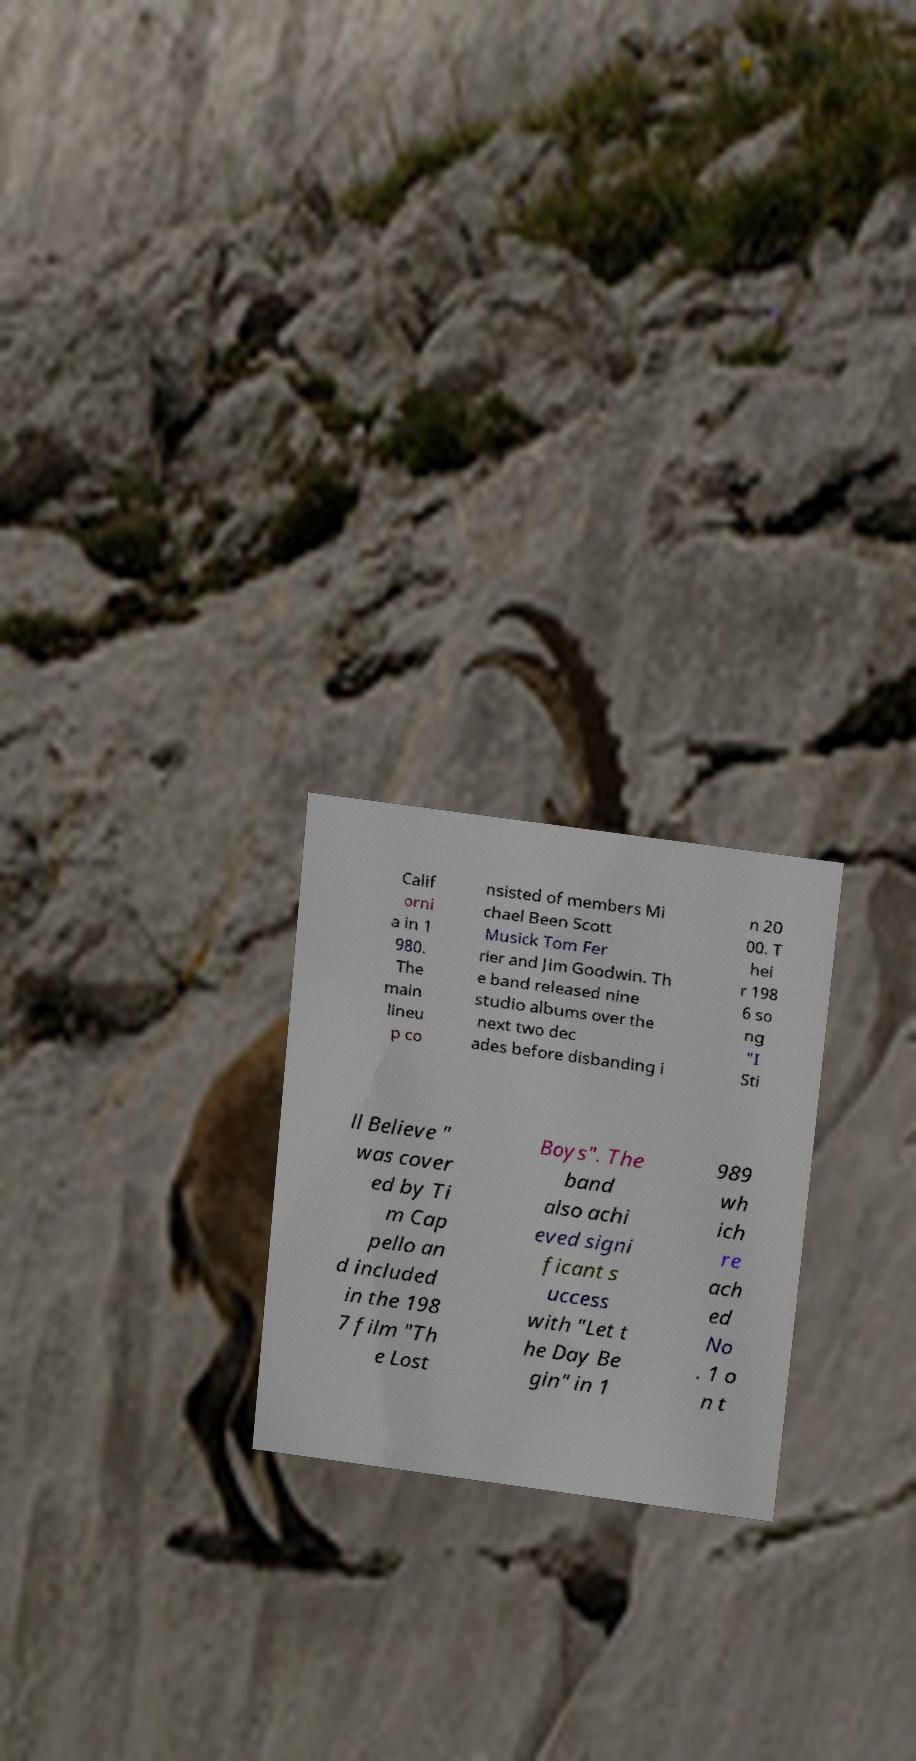I need the written content from this picture converted into text. Can you do that? Calif orni a in 1 980. The main lineu p co nsisted of members Mi chael Been Scott Musick Tom Fer rier and Jim Goodwin. Th e band released nine studio albums over the next two dec ades before disbanding i n 20 00. T hei r 198 6 so ng "I Sti ll Believe " was cover ed by Ti m Cap pello an d included in the 198 7 film "Th e Lost Boys". The band also achi eved signi ficant s uccess with "Let t he Day Be gin" in 1 989 wh ich re ach ed No . 1 o n t 